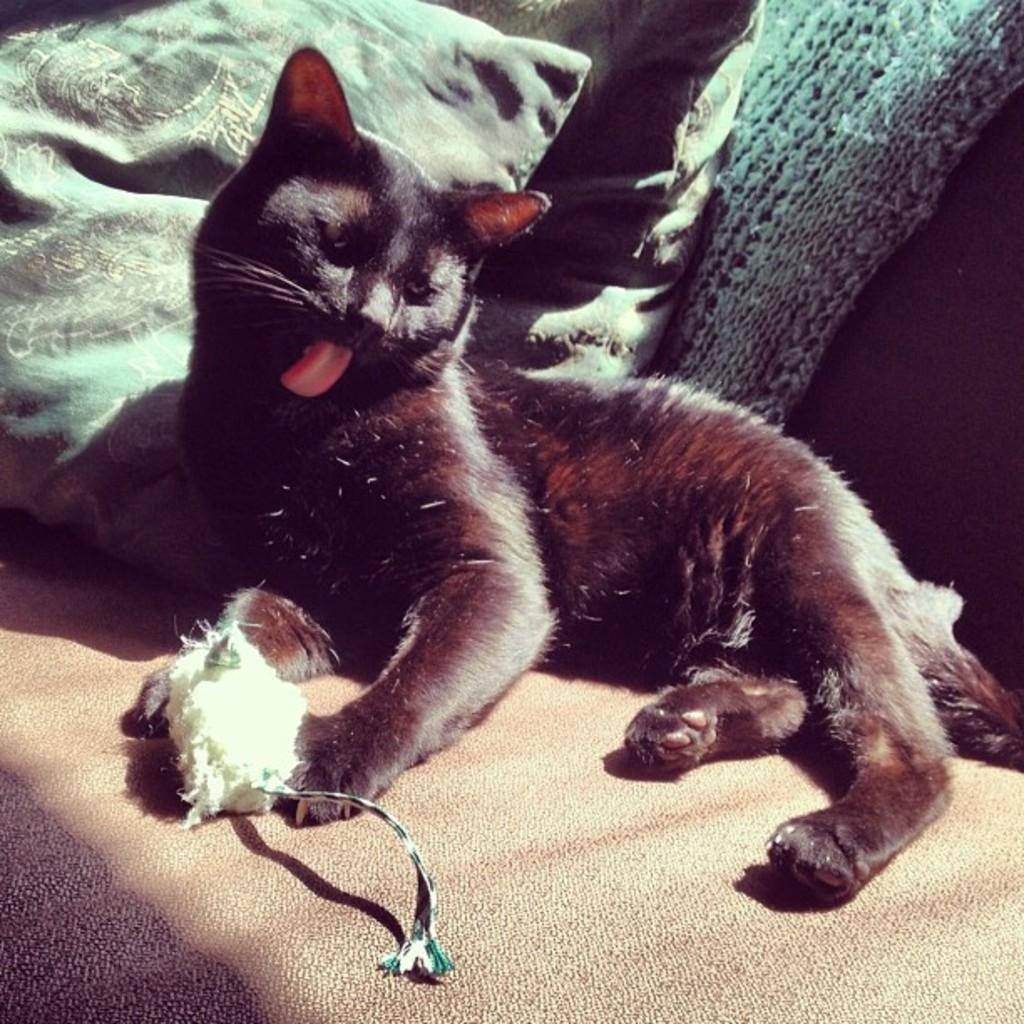Can you describe this image briefly? In the center of the image we can see a cat lying on the sofa and there are cushions placed on it. 